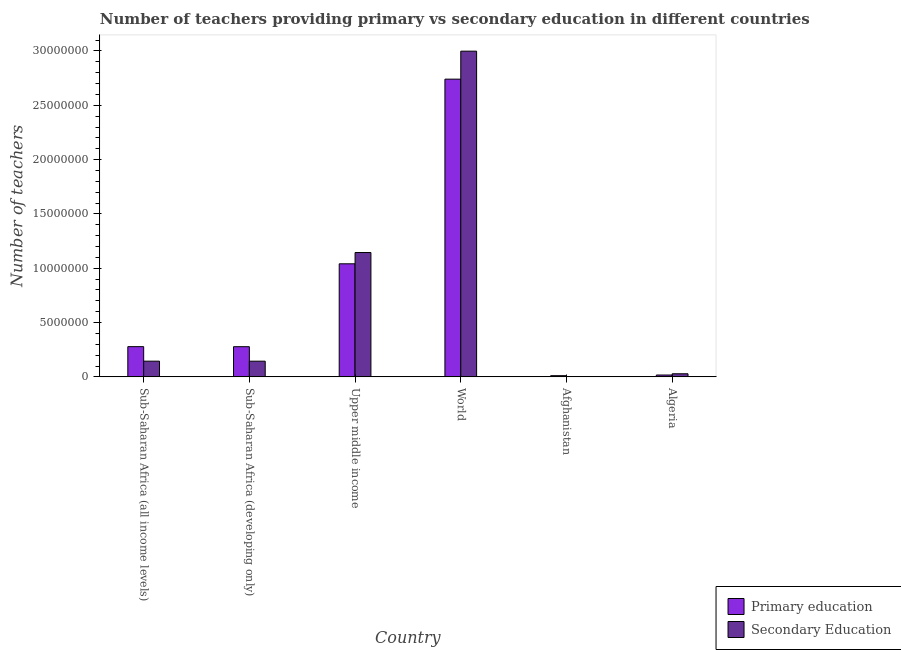How many different coloured bars are there?
Your response must be concise. 2. How many groups of bars are there?
Your answer should be very brief. 6. Are the number of bars per tick equal to the number of legend labels?
Provide a short and direct response. Yes. How many bars are there on the 6th tick from the left?
Ensure brevity in your answer.  2. How many bars are there on the 5th tick from the right?
Give a very brief answer. 2. What is the label of the 5th group of bars from the left?
Make the answer very short. Afghanistan. What is the number of primary teachers in Algeria?
Offer a terse response. 1.71e+05. Across all countries, what is the maximum number of primary teachers?
Make the answer very short. 2.74e+07. Across all countries, what is the minimum number of secondary teachers?
Your response must be concise. 3.28e+04. In which country was the number of primary teachers minimum?
Make the answer very short. Afghanistan. What is the total number of primary teachers in the graph?
Give a very brief answer. 4.37e+07. What is the difference between the number of primary teachers in Afghanistan and that in Upper middle income?
Offer a terse response. -1.03e+07. What is the difference between the number of primary teachers in Sub-Saharan Africa (all income levels) and the number of secondary teachers in Sub-Saharan Africa (developing only)?
Keep it short and to the point. 1.34e+06. What is the average number of secondary teachers per country?
Ensure brevity in your answer.  7.44e+06. What is the difference between the number of secondary teachers and number of primary teachers in Sub-Saharan Africa (all income levels)?
Offer a terse response. -1.34e+06. What is the ratio of the number of secondary teachers in Algeria to that in Sub-Saharan Africa (all income levels)?
Your response must be concise. 0.2. Is the number of secondary teachers in Algeria less than that in Sub-Saharan Africa (all income levels)?
Provide a succinct answer. Yes. What is the difference between the highest and the second highest number of primary teachers?
Make the answer very short. 1.70e+07. What is the difference between the highest and the lowest number of secondary teachers?
Ensure brevity in your answer.  3.00e+07. In how many countries, is the number of secondary teachers greater than the average number of secondary teachers taken over all countries?
Ensure brevity in your answer.  2. What does the 2nd bar from the left in Sub-Saharan Africa (all income levels) represents?
Provide a succinct answer. Secondary Education. What does the 1st bar from the right in World represents?
Offer a terse response. Secondary Education. Are all the bars in the graph horizontal?
Give a very brief answer. No. How many countries are there in the graph?
Make the answer very short. 6. How many legend labels are there?
Make the answer very short. 2. What is the title of the graph?
Offer a terse response. Number of teachers providing primary vs secondary education in different countries. What is the label or title of the X-axis?
Your answer should be very brief. Country. What is the label or title of the Y-axis?
Offer a very short reply. Number of teachers. What is the Number of teachers of Primary education in Sub-Saharan Africa (all income levels)?
Provide a short and direct response. 2.78e+06. What is the Number of teachers of Secondary Education in Sub-Saharan Africa (all income levels)?
Offer a very short reply. 1.45e+06. What is the Number of teachers of Primary education in Sub-Saharan Africa (developing only)?
Give a very brief answer. 2.78e+06. What is the Number of teachers in Secondary Education in Sub-Saharan Africa (developing only)?
Give a very brief answer. 1.44e+06. What is the Number of teachers of Primary education in Upper middle income?
Your response must be concise. 1.04e+07. What is the Number of teachers of Secondary Education in Upper middle income?
Ensure brevity in your answer.  1.14e+07. What is the Number of teachers in Primary education in World?
Offer a very short reply. 2.74e+07. What is the Number of teachers of Secondary Education in World?
Offer a terse response. 3.00e+07. What is the Number of teachers in Primary education in Afghanistan?
Make the answer very short. 1.10e+05. What is the Number of teachers in Secondary Education in Afghanistan?
Keep it short and to the point. 3.28e+04. What is the Number of teachers of Primary education in Algeria?
Your answer should be compact. 1.71e+05. What is the Number of teachers in Secondary Education in Algeria?
Make the answer very short. 2.86e+05. Across all countries, what is the maximum Number of teachers in Primary education?
Make the answer very short. 2.74e+07. Across all countries, what is the maximum Number of teachers of Secondary Education?
Ensure brevity in your answer.  3.00e+07. Across all countries, what is the minimum Number of teachers of Primary education?
Ensure brevity in your answer.  1.10e+05. Across all countries, what is the minimum Number of teachers of Secondary Education?
Provide a short and direct response. 3.28e+04. What is the total Number of teachers in Primary education in the graph?
Offer a very short reply. 4.37e+07. What is the total Number of teachers of Secondary Education in the graph?
Provide a succinct answer. 4.46e+07. What is the difference between the Number of teachers in Primary education in Sub-Saharan Africa (all income levels) and that in Sub-Saharan Africa (developing only)?
Your response must be concise. 3635.5. What is the difference between the Number of teachers in Secondary Education in Sub-Saharan Africa (all income levels) and that in Sub-Saharan Africa (developing only)?
Your response must be concise. 1785.5. What is the difference between the Number of teachers in Primary education in Sub-Saharan Africa (all income levels) and that in Upper middle income?
Ensure brevity in your answer.  -7.63e+06. What is the difference between the Number of teachers in Secondary Education in Sub-Saharan Africa (all income levels) and that in Upper middle income?
Make the answer very short. -1.00e+07. What is the difference between the Number of teachers of Primary education in Sub-Saharan Africa (all income levels) and that in World?
Keep it short and to the point. -2.46e+07. What is the difference between the Number of teachers of Secondary Education in Sub-Saharan Africa (all income levels) and that in World?
Offer a very short reply. -2.85e+07. What is the difference between the Number of teachers of Primary education in Sub-Saharan Africa (all income levels) and that in Afghanistan?
Offer a terse response. 2.67e+06. What is the difference between the Number of teachers of Secondary Education in Sub-Saharan Africa (all income levels) and that in Afghanistan?
Make the answer very short. 1.41e+06. What is the difference between the Number of teachers in Primary education in Sub-Saharan Africa (all income levels) and that in Algeria?
Make the answer very short. 2.61e+06. What is the difference between the Number of teachers in Secondary Education in Sub-Saharan Africa (all income levels) and that in Algeria?
Your answer should be compact. 1.16e+06. What is the difference between the Number of teachers of Primary education in Sub-Saharan Africa (developing only) and that in Upper middle income?
Give a very brief answer. -7.63e+06. What is the difference between the Number of teachers in Secondary Education in Sub-Saharan Africa (developing only) and that in Upper middle income?
Ensure brevity in your answer.  -1.00e+07. What is the difference between the Number of teachers in Primary education in Sub-Saharan Africa (developing only) and that in World?
Your response must be concise. -2.46e+07. What is the difference between the Number of teachers in Secondary Education in Sub-Saharan Africa (developing only) and that in World?
Your answer should be very brief. -2.85e+07. What is the difference between the Number of teachers in Primary education in Sub-Saharan Africa (developing only) and that in Afghanistan?
Offer a very short reply. 2.67e+06. What is the difference between the Number of teachers of Secondary Education in Sub-Saharan Africa (developing only) and that in Afghanistan?
Provide a short and direct response. 1.41e+06. What is the difference between the Number of teachers of Primary education in Sub-Saharan Africa (developing only) and that in Algeria?
Provide a succinct answer. 2.61e+06. What is the difference between the Number of teachers of Secondary Education in Sub-Saharan Africa (developing only) and that in Algeria?
Offer a terse response. 1.16e+06. What is the difference between the Number of teachers in Primary education in Upper middle income and that in World?
Keep it short and to the point. -1.70e+07. What is the difference between the Number of teachers of Secondary Education in Upper middle income and that in World?
Offer a very short reply. -1.85e+07. What is the difference between the Number of teachers of Primary education in Upper middle income and that in Afghanistan?
Provide a succinct answer. 1.03e+07. What is the difference between the Number of teachers of Secondary Education in Upper middle income and that in Afghanistan?
Provide a succinct answer. 1.14e+07. What is the difference between the Number of teachers of Primary education in Upper middle income and that in Algeria?
Make the answer very short. 1.02e+07. What is the difference between the Number of teachers in Secondary Education in Upper middle income and that in Algeria?
Ensure brevity in your answer.  1.12e+07. What is the difference between the Number of teachers of Primary education in World and that in Afghanistan?
Keep it short and to the point. 2.73e+07. What is the difference between the Number of teachers in Secondary Education in World and that in Afghanistan?
Your answer should be very brief. 3.00e+07. What is the difference between the Number of teachers of Primary education in World and that in Algeria?
Offer a very short reply. 2.72e+07. What is the difference between the Number of teachers of Secondary Education in World and that in Algeria?
Your answer should be very brief. 2.97e+07. What is the difference between the Number of teachers in Primary education in Afghanistan and that in Algeria?
Offer a very short reply. -6.05e+04. What is the difference between the Number of teachers in Secondary Education in Afghanistan and that in Algeria?
Give a very brief answer. -2.53e+05. What is the difference between the Number of teachers of Primary education in Sub-Saharan Africa (all income levels) and the Number of teachers of Secondary Education in Sub-Saharan Africa (developing only)?
Provide a succinct answer. 1.34e+06. What is the difference between the Number of teachers of Primary education in Sub-Saharan Africa (all income levels) and the Number of teachers of Secondary Education in Upper middle income?
Your answer should be compact. -8.66e+06. What is the difference between the Number of teachers in Primary education in Sub-Saharan Africa (all income levels) and the Number of teachers in Secondary Education in World?
Keep it short and to the point. -2.72e+07. What is the difference between the Number of teachers in Primary education in Sub-Saharan Africa (all income levels) and the Number of teachers in Secondary Education in Afghanistan?
Provide a short and direct response. 2.75e+06. What is the difference between the Number of teachers in Primary education in Sub-Saharan Africa (all income levels) and the Number of teachers in Secondary Education in Algeria?
Offer a terse response. 2.50e+06. What is the difference between the Number of teachers of Primary education in Sub-Saharan Africa (developing only) and the Number of teachers of Secondary Education in Upper middle income?
Provide a short and direct response. -8.67e+06. What is the difference between the Number of teachers in Primary education in Sub-Saharan Africa (developing only) and the Number of teachers in Secondary Education in World?
Make the answer very short. -2.72e+07. What is the difference between the Number of teachers of Primary education in Sub-Saharan Africa (developing only) and the Number of teachers of Secondary Education in Afghanistan?
Provide a short and direct response. 2.75e+06. What is the difference between the Number of teachers of Primary education in Sub-Saharan Africa (developing only) and the Number of teachers of Secondary Education in Algeria?
Keep it short and to the point. 2.49e+06. What is the difference between the Number of teachers of Primary education in Upper middle income and the Number of teachers of Secondary Education in World?
Offer a terse response. -1.96e+07. What is the difference between the Number of teachers in Primary education in Upper middle income and the Number of teachers in Secondary Education in Afghanistan?
Your answer should be compact. 1.04e+07. What is the difference between the Number of teachers of Primary education in Upper middle income and the Number of teachers of Secondary Education in Algeria?
Your response must be concise. 1.01e+07. What is the difference between the Number of teachers of Primary education in World and the Number of teachers of Secondary Education in Afghanistan?
Your answer should be compact. 2.74e+07. What is the difference between the Number of teachers in Primary education in World and the Number of teachers in Secondary Education in Algeria?
Offer a very short reply. 2.71e+07. What is the difference between the Number of teachers of Primary education in Afghanistan and the Number of teachers of Secondary Education in Algeria?
Give a very brief answer. -1.75e+05. What is the average Number of teachers of Primary education per country?
Your response must be concise. 7.28e+06. What is the average Number of teachers of Secondary Education per country?
Your answer should be very brief. 7.44e+06. What is the difference between the Number of teachers of Primary education and Number of teachers of Secondary Education in Sub-Saharan Africa (all income levels)?
Your response must be concise. 1.34e+06. What is the difference between the Number of teachers of Primary education and Number of teachers of Secondary Education in Sub-Saharan Africa (developing only)?
Your answer should be compact. 1.33e+06. What is the difference between the Number of teachers in Primary education and Number of teachers in Secondary Education in Upper middle income?
Your response must be concise. -1.04e+06. What is the difference between the Number of teachers in Primary education and Number of teachers in Secondary Education in World?
Offer a very short reply. -2.58e+06. What is the difference between the Number of teachers in Primary education and Number of teachers in Secondary Education in Afghanistan?
Offer a very short reply. 7.75e+04. What is the difference between the Number of teachers in Primary education and Number of teachers in Secondary Education in Algeria?
Make the answer very short. -1.15e+05. What is the ratio of the Number of teachers of Primary education in Sub-Saharan Africa (all income levels) to that in Sub-Saharan Africa (developing only)?
Your answer should be compact. 1. What is the ratio of the Number of teachers in Secondary Education in Sub-Saharan Africa (all income levels) to that in Sub-Saharan Africa (developing only)?
Provide a short and direct response. 1. What is the ratio of the Number of teachers in Primary education in Sub-Saharan Africa (all income levels) to that in Upper middle income?
Ensure brevity in your answer.  0.27. What is the ratio of the Number of teachers in Secondary Education in Sub-Saharan Africa (all income levels) to that in Upper middle income?
Your answer should be compact. 0.13. What is the ratio of the Number of teachers of Primary education in Sub-Saharan Africa (all income levels) to that in World?
Ensure brevity in your answer.  0.1. What is the ratio of the Number of teachers of Secondary Education in Sub-Saharan Africa (all income levels) to that in World?
Keep it short and to the point. 0.05. What is the ratio of the Number of teachers of Primary education in Sub-Saharan Africa (all income levels) to that in Afghanistan?
Keep it short and to the point. 25.22. What is the ratio of the Number of teachers in Secondary Education in Sub-Saharan Africa (all income levels) to that in Afghanistan?
Offer a very short reply. 44.06. What is the ratio of the Number of teachers in Primary education in Sub-Saharan Africa (all income levels) to that in Algeria?
Offer a terse response. 16.29. What is the ratio of the Number of teachers in Secondary Education in Sub-Saharan Africa (all income levels) to that in Algeria?
Make the answer very short. 5.06. What is the ratio of the Number of teachers in Primary education in Sub-Saharan Africa (developing only) to that in Upper middle income?
Offer a very short reply. 0.27. What is the ratio of the Number of teachers of Secondary Education in Sub-Saharan Africa (developing only) to that in Upper middle income?
Your answer should be compact. 0.13. What is the ratio of the Number of teachers in Primary education in Sub-Saharan Africa (developing only) to that in World?
Offer a very short reply. 0.1. What is the ratio of the Number of teachers in Secondary Education in Sub-Saharan Africa (developing only) to that in World?
Provide a succinct answer. 0.05. What is the ratio of the Number of teachers of Primary education in Sub-Saharan Africa (developing only) to that in Afghanistan?
Ensure brevity in your answer.  25.18. What is the ratio of the Number of teachers in Secondary Education in Sub-Saharan Africa (developing only) to that in Afghanistan?
Make the answer very short. 44.01. What is the ratio of the Number of teachers of Primary education in Sub-Saharan Africa (developing only) to that in Algeria?
Your answer should be very brief. 16.27. What is the ratio of the Number of teachers in Secondary Education in Sub-Saharan Africa (developing only) to that in Algeria?
Offer a very short reply. 5.05. What is the ratio of the Number of teachers in Primary education in Upper middle income to that in World?
Your answer should be compact. 0.38. What is the ratio of the Number of teachers in Secondary Education in Upper middle income to that in World?
Your answer should be compact. 0.38. What is the ratio of the Number of teachers of Primary education in Upper middle income to that in Afghanistan?
Offer a terse response. 94.35. What is the ratio of the Number of teachers of Secondary Education in Upper middle income to that in Afghanistan?
Provide a succinct answer. 348.8. What is the ratio of the Number of teachers in Primary education in Upper middle income to that in Algeria?
Keep it short and to the point. 60.95. What is the ratio of the Number of teachers of Secondary Education in Upper middle income to that in Algeria?
Your answer should be very brief. 40.06. What is the ratio of the Number of teachers in Primary education in World to that in Afghanistan?
Make the answer very short. 248.46. What is the ratio of the Number of teachers in Secondary Education in World to that in Afghanistan?
Keep it short and to the point. 913.69. What is the ratio of the Number of teachers of Primary education in World to that in Algeria?
Ensure brevity in your answer.  160.5. What is the ratio of the Number of teachers in Secondary Education in World to that in Algeria?
Your answer should be compact. 104.93. What is the ratio of the Number of teachers in Primary education in Afghanistan to that in Algeria?
Your answer should be compact. 0.65. What is the ratio of the Number of teachers of Secondary Education in Afghanistan to that in Algeria?
Your response must be concise. 0.11. What is the difference between the highest and the second highest Number of teachers of Primary education?
Offer a terse response. 1.70e+07. What is the difference between the highest and the second highest Number of teachers of Secondary Education?
Ensure brevity in your answer.  1.85e+07. What is the difference between the highest and the lowest Number of teachers in Primary education?
Ensure brevity in your answer.  2.73e+07. What is the difference between the highest and the lowest Number of teachers in Secondary Education?
Offer a terse response. 3.00e+07. 